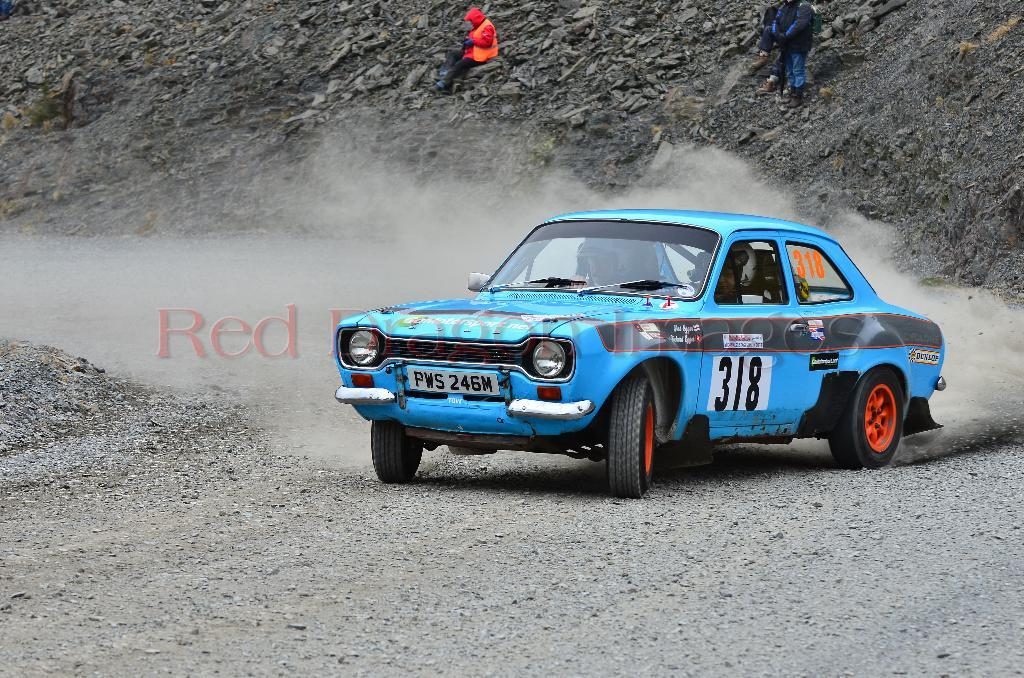What are the people doing in the image? The people are riding a vehicle on the road. What can be seen in the background of the image? There are stones and people visible in the background. What is present in the middle of the image? There is a watermark in the middle of the image. Can you hear the noise of the waves crashing in the image? There are no waves or sounds present in the image, as it features people riding a vehicle on a road with a background of stones and people. 